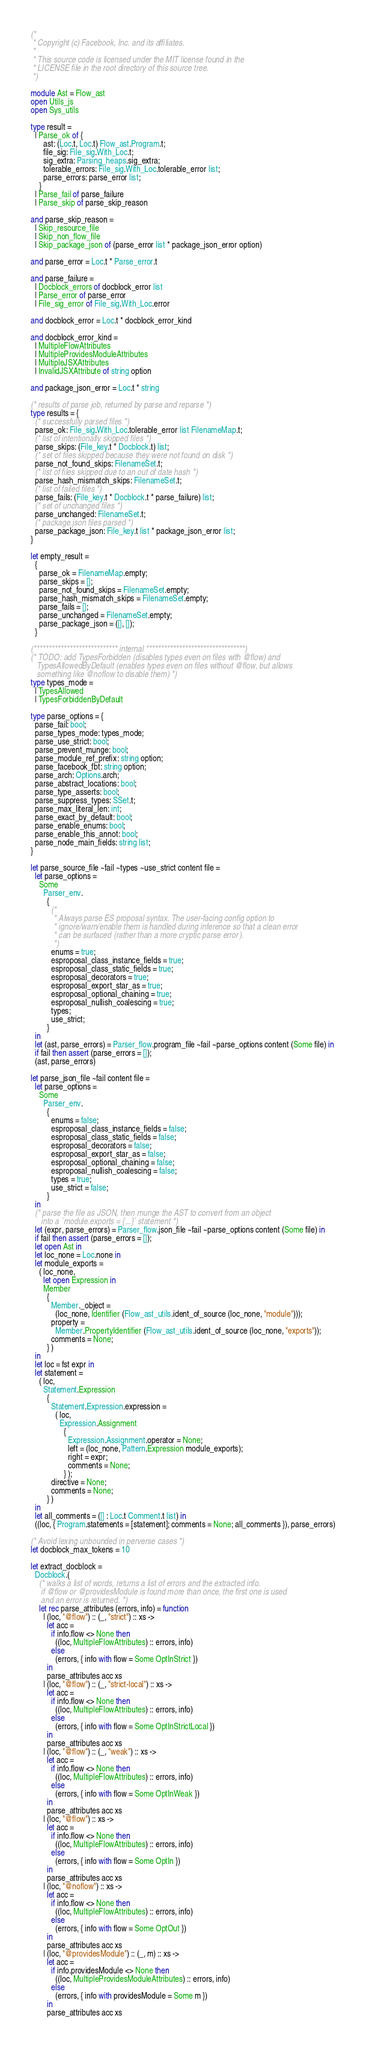Convert code to text. <code><loc_0><loc_0><loc_500><loc_500><_OCaml_>(*
 * Copyright (c) Facebook, Inc. and its affiliates.
 *
 * This source code is licensed under the MIT license found in the
 * LICENSE file in the root directory of this source tree.
 *)

module Ast = Flow_ast
open Utils_js
open Sys_utils

type result =
  | Parse_ok of {
      ast: (Loc.t, Loc.t) Flow_ast.Program.t;
      file_sig: File_sig.With_Loc.t;
      sig_extra: Parsing_heaps.sig_extra;
      tolerable_errors: File_sig.With_Loc.tolerable_error list;
      parse_errors: parse_error list;
    }
  | Parse_fail of parse_failure
  | Parse_skip of parse_skip_reason

and parse_skip_reason =
  | Skip_resource_file
  | Skip_non_flow_file
  | Skip_package_json of (parse_error list * package_json_error option)

and parse_error = Loc.t * Parse_error.t

and parse_failure =
  | Docblock_errors of docblock_error list
  | Parse_error of parse_error
  | File_sig_error of File_sig.With_Loc.error

and docblock_error = Loc.t * docblock_error_kind

and docblock_error_kind =
  | MultipleFlowAttributes
  | MultipleProvidesModuleAttributes
  | MultipleJSXAttributes
  | InvalidJSXAttribute of string option

and package_json_error = Loc.t * string

(* results of parse job, returned by parse and reparse *)
type results = {
  (* successfully parsed files *)
  parse_ok: File_sig.With_Loc.tolerable_error list FilenameMap.t;
  (* list of intentionally skipped files *)
  parse_skips: (File_key.t * Docblock.t) list;
  (* set of files skipped because they were not found on disk *)
  parse_not_found_skips: FilenameSet.t;
  (* list of files skipped due to an out of date hash *)
  parse_hash_mismatch_skips: FilenameSet.t;
  (* list of failed files *)
  parse_fails: (File_key.t * Docblock.t * parse_failure) list;
  (* set of unchanged files *)
  parse_unchanged: FilenameSet.t;
  (* package.json files parsed *)
  parse_package_json: File_key.t list * package_json_error list;
}

let empty_result =
  {
    parse_ok = FilenameMap.empty;
    parse_skips = [];
    parse_not_found_skips = FilenameSet.empty;
    parse_hash_mismatch_skips = FilenameSet.empty;
    parse_fails = [];
    parse_unchanged = FilenameSet.empty;
    parse_package_json = ([], []);
  }

(**************************** internal *********************************)
(* TODO: add TypesForbidden (disables types even on files with @flow) and
   TypesAllowedByDefault (enables types even on files without @flow, but allows
   something like @noflow to disable them) *)
type types_mode =
  | TypesAllowed
  | TypesForbiddenByDefault

type parse_options = {
  parse_fail: bool;
  parse_types_mode: types_mode;
  parse_use_strict: bool;
  parse_prevent_munge: bool;
  parse_module_ref_prefix: string option;
  parse_facebook_fbt: string option;
  parse_arch: Options.arch;
  parse_abstract_locations: bool;
  parse_type_asserts: bool;
  parse_suppress_types: SSet.t;
  parse_max_literal_len: int;
  parse_exact_by_default: bool;
  parse_enable_enums: bool;
  parse_enable_this_annot: bool;
  parse_node_main_fields: string list;
}

let parse_source_file ~fail ~types ~use_strict content file =
  let parse_options =
    Some
      Parser_env.
        {
          (*
           * Always parse ES proposal syntax. The user-facing config option to
           * ignore/warn/enable them is handled during inference so that a clean error
           * can be surfaced (rather than a more cryptic parse error).
           *)
          enums = true;
          esproposal_class_instance_fields = true;
          esproposal_class_static_fields = true;
          esproposal_decorators = true;
          esproposal_export_star_as = true;
          esproposal_optional_chaining = true;
          esproposal_nullish_coalescing = true;
          types;
          use_strict;
        }
  in
  let (ast, parse_errors) = Parser_flow.program_file ~fail ~parse_options content (Some file) in
  if fail then assert (parse_errors = []);
  (ast, parse_errors)

let parse_json_file ~fail content file =
  let parse_options =
    Some
      Parser_env.
        {
          enums = false;
          esproposal_class_instance_fields = false;
          esproposal_class_static_fields = false;
          esproposal_decorators = false;
          esproposal_export_star_as = false;
          esproposal_optional_chaining = false;
          esproposal_nullish_coalescing = false;
          types = true;
          use_strict = false;
        }
  in
  (* parse the file as JSON, then munge the AST to convert from an object
     into a `module.exports = {...}` statement *)
  let (expr, parse_errors) = Parser_flow.json_file ~fail ~parse_options content (Some file) in
  if fail then assert (parse_errors = []);
  let open Ast in
  let loc_none = Loc.none in
  let module_exports =
    ( loc_none,
      let open Expression in
      Member
        {
          Member._object =
            (loc_none, Identifier (Flow_ast_utils.ident_of_source (loc_none, "module")));
          property =
            Member.PropertyIdentifier (Flow_ast_utils.ident_of_source (loc_none, "exports"));
          comments = None;
        } )
  in
  let loc = fst expr in
  let statement =
    ( loc,
      Statement.Expression
        {
          Statement.Expression.expression =
            ( loc,
              Expression.Assignment
                {
                  Expression.Assignment.operator = None;
                  left = (loc_none, Pattern.Expression module_exports);
                  right = expr;
                  comments = None;
                } );
          directive = None;
          comments = None;
        } )
  in
  let all_comments = ([] : Loc.t Comment.t list) in
  ((loc, { Program.statements = [statement]; comments = None; all_comments }), parse_errors)

(* Avoid lexing unbounded in perverse cases *)
let docblock_max_tokens = 10

let extract_docblock =
  Docblock.(
    (* walks a list of words, returns a list of errors and the extracted info.
     if @flow or @providesModule is found more than once, the first one is used
     and an error is returned. *)
    let rec parse_attributes (errors, info) = function
      | (loc, "@flow") :: (_, "strict") :: xs ->
        let acc =
          if info.flow <> None then
            ((loc, MultipleFlowAttributes) :: errors, info)
          else
            (errors, { info with flow = Some OptInStrict })
        in
        parse_attributes acc xs
      | (loc, "@flow") :: (_, "strict-local") :: xs ->
        let acc =
          if info.flow <> None then
            ((loc, MultipleFlowAttributes) :: errors, info)
          else
            (errors, { info with flow = Some OptInStrictLocal })
        in
        parse_attributes acc xs
      | (loc, "@flow") :: (_, "weak") :: xs ->
        let acc =
          if info.flow <> None then
            ((loc, MultipleFlowAttributes) :: errors, info)
          else
            (errors, { info with flow = Some OptInWeak })
        in
        parse_attributes acc xs
      | (loc, "@flow") :: xs ->
        let acc =
          if info.flow <> None then
            ((loc, MultipleFlowAttributes) :: errors, info)
          else
            (errors, { info with flow = Some OptIn })
        in
        parse_attributes acc xs
      | (loc, "@noflow") :: xs ->
        let acc =
          if info.flow <> None then
            ((loc, MultipleFlowAttributes) :: errors, info)
          else
            (errors, { info with flow = Some OptOut })
        in
        parse_attributes acc xs
      | (loc, "@providesModule") :: (_, m) :: xs ->
        let acc =
          if info.providesModule <> None then
            ((loc, MultipleProvidesModuleAttributes) :: errors, info)
          else
            (errors, { info with providesModule = Some m })
        in
        parse_attributes acc xs</code> 